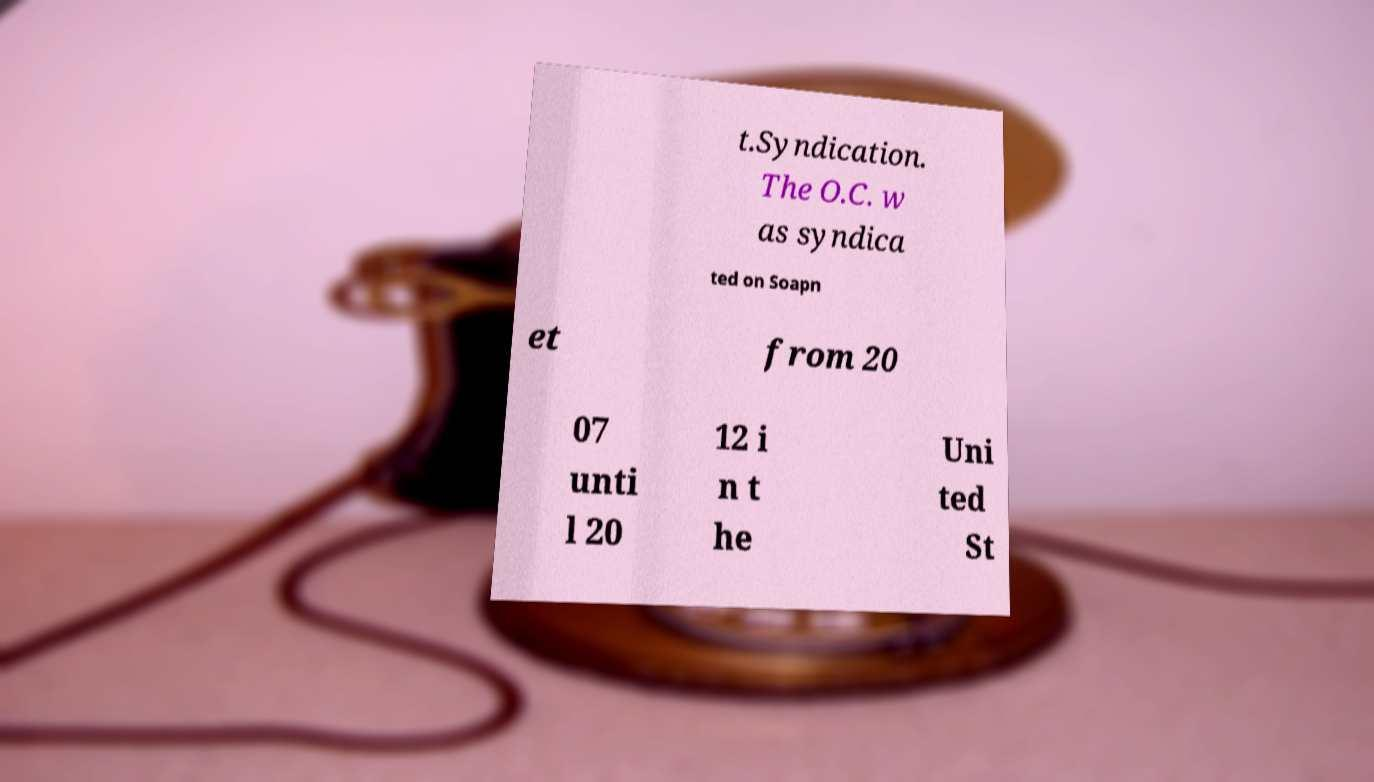Please read and relay the text visible in this image. What does it say? t.Syndication. The O.C. w as syndica ted on Soapn et from 20 07 unti l 20 12 i n t he Uni ted St 